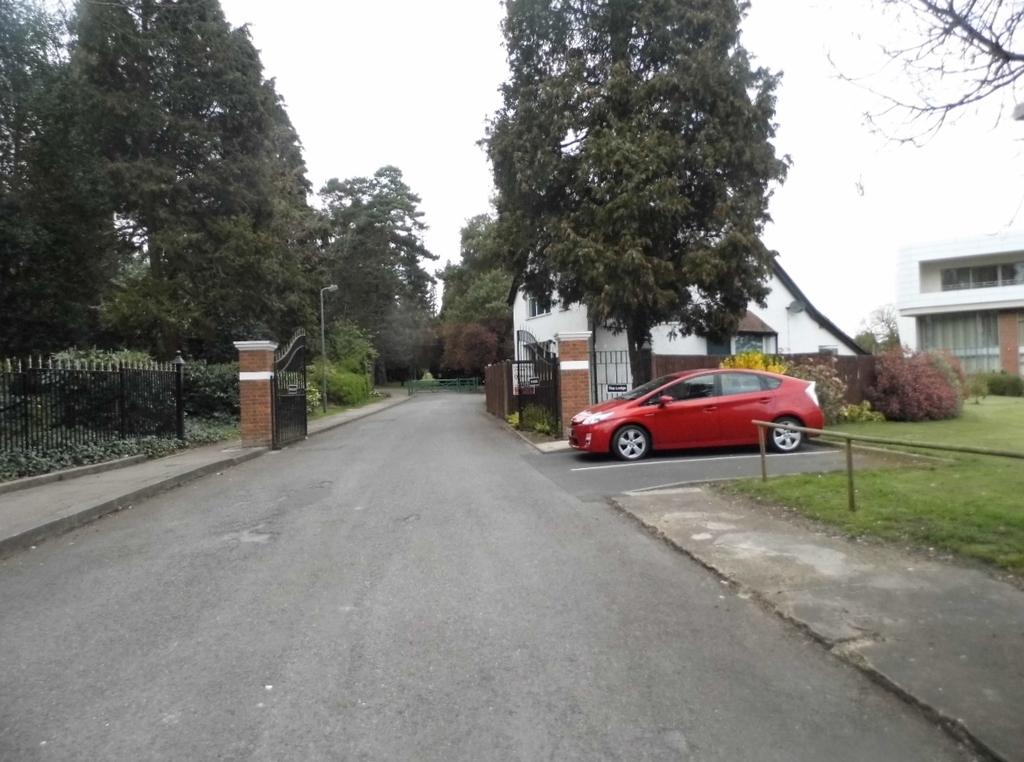What type of vehicle can be seen in the image? There is a red vehicle in the image. What natural elements are visible in the image? Trees are visible in the image. What is the color of the trees? The trees are green. What man-made structure is present in the image? There is a building in the image. What is the color of the building? The building is white. What part of the natural environment is visible in the image? The sky is visible in the image. What is the color of the sky? The sky is white. How many divisions of pears can be seen in the image? There are no pears present in the image, so it is not possible to determine the number of divisions. What type of payment is being made in the image? There is no payment being made in the image. 